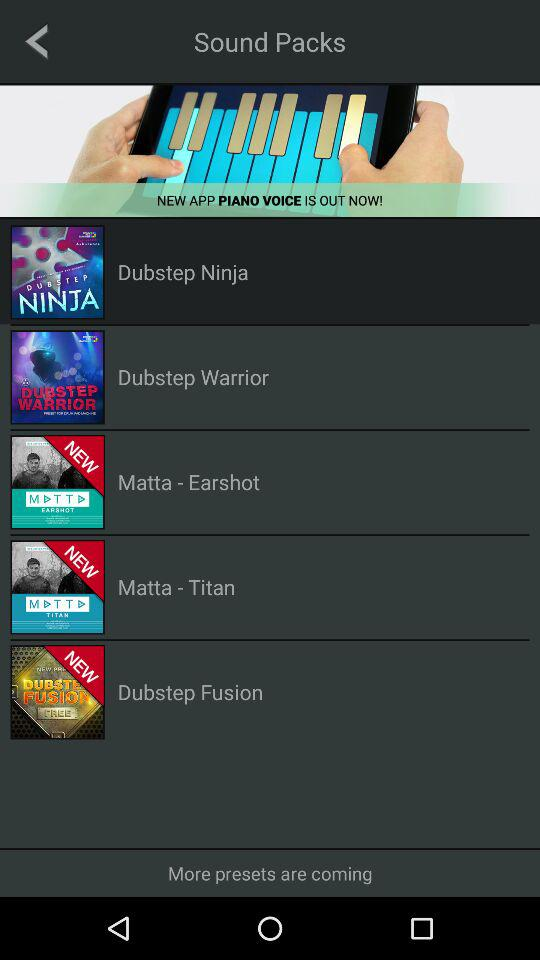Which version of the application is this?
When the provided information is insufficient, respond with <no answer>. <no answer> 